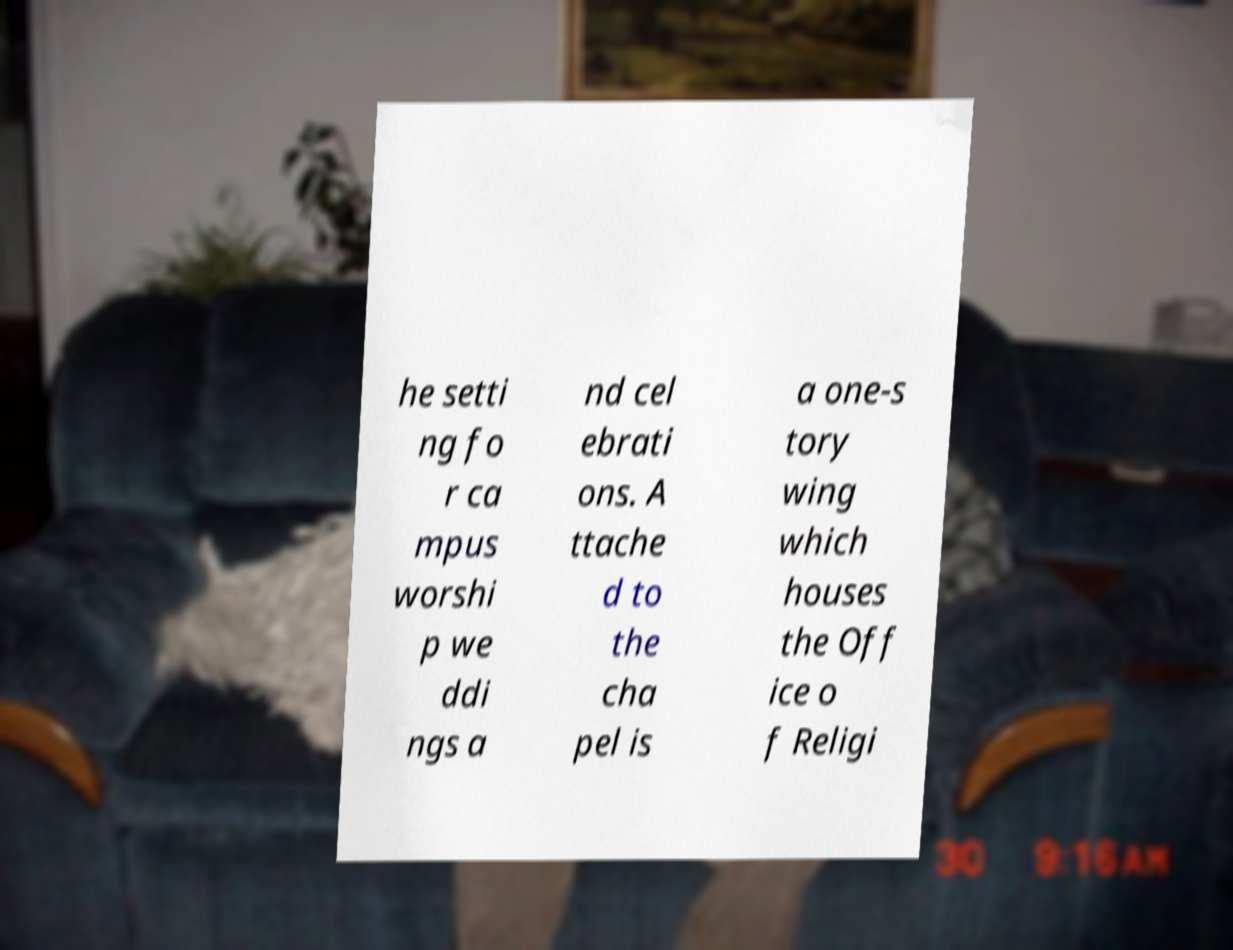There's text embedded in this image that I need extracted. Can you transcribe it verbatim? he setti ng fo r ca mpus worshi p we ddi ngs a nd cel ebrati ons. A ttache d to the cha pel is a one-s tory wing which houses the Off ice o f Religi 